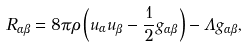<formula> <loc_0><loc_0><loc_500><loc_500>R _ { \alpha \beta } = 8 \pi \rho \left ( u _ { \alpha } u _ { \beta } - \frac { 1 } { 2 } g _ { \alpha \beta } \right ) - \Lambda g _ { \alpha \beta } ,</formula> 